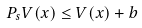Convert formula to latex. <formula><loc_0><loc_0><loc_500><loc_500>P _ { s } V ( x ) \leq V ( x ) + b</formula> 